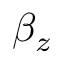<formula> <loc_0><loc_0><loc_500><loc_500>\beta _ { z }</formula> 